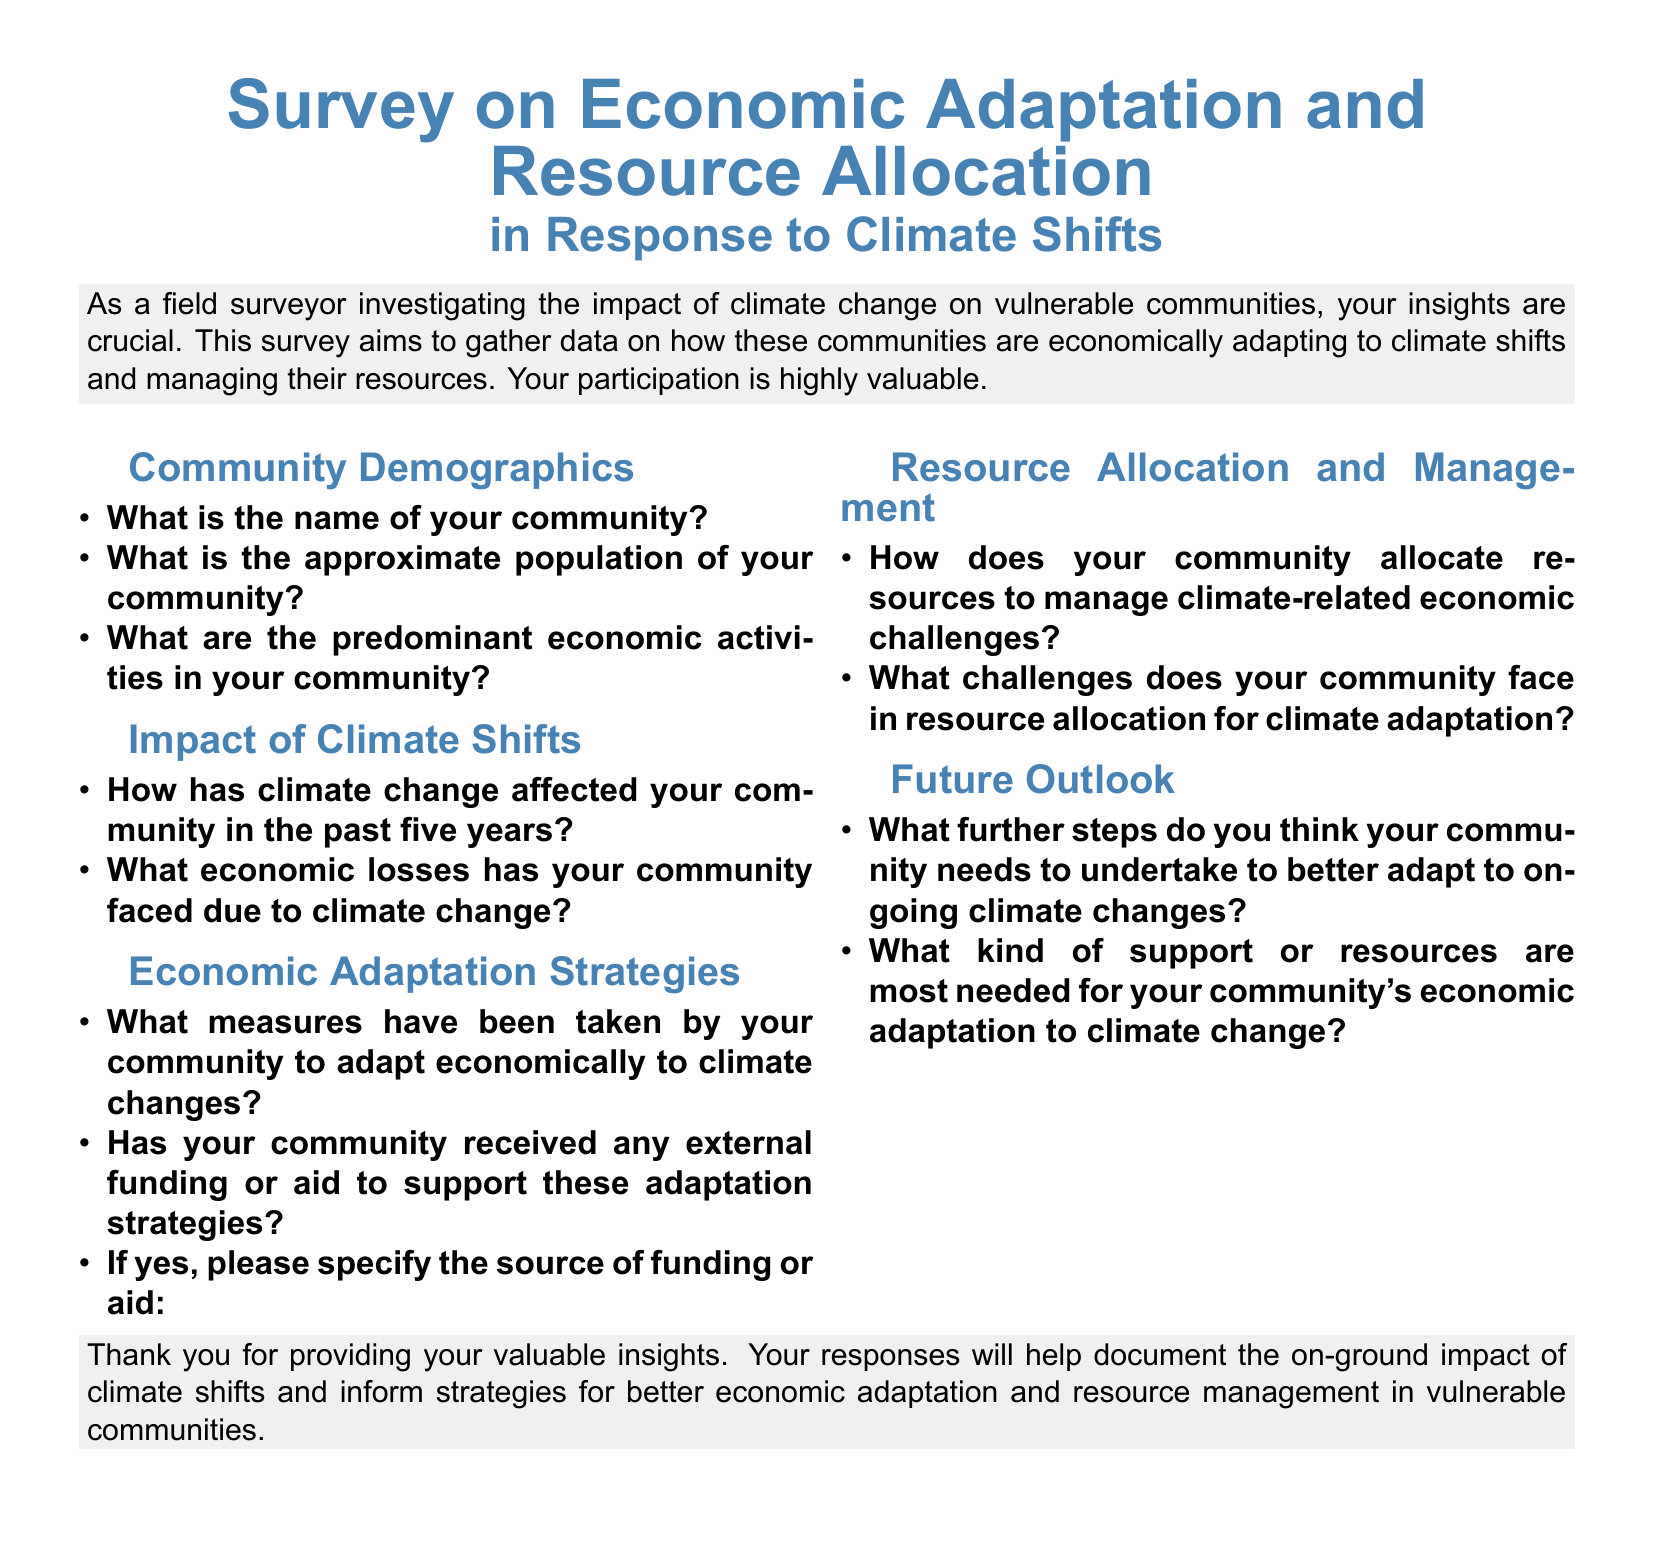What is the name of your community? This question retrieves the community name as per the survey's demographic section.
Answer: Community name What are the predominant economic activities in your community? This question seeks to identify the key economic activities listed under community demographics.
Answer: Economic activities How has climate change affected your community in the past five years? This question requires a summary of climate impacts, found in the impact section of the survey.
Answer: Climate effects What economic losses has your community faced? This question asks for specific economic losses related to climate shifts, also found in the impact section.
Answer: Economic losses What measures have been taken by your community to adapt economically? This question examines the adaptation strategies in the survey, requiring consolidation of that section's information.
Answer: Economic adaptation measures Has your community received any external funding or aid? This question asks whether the community has accessed external resources for adaptation, found under economic adaptation strategies.
Answer: External funding status What challenges does your community face in resource allocation? This requires summarizing the challenges identified in resource management in response to climate impacts.
Answer: Resource allocation challenges What further steps do you think your community needs to undertake? This question looks for future actions regarding climate adaptation as discussed in the future outlook section.
Answer: Further steps needed What kind of support or resources are most needed? This question seeks to identify specific support required, based on the community's needs related to economic adaptation.
Answer: Needed support or resources 